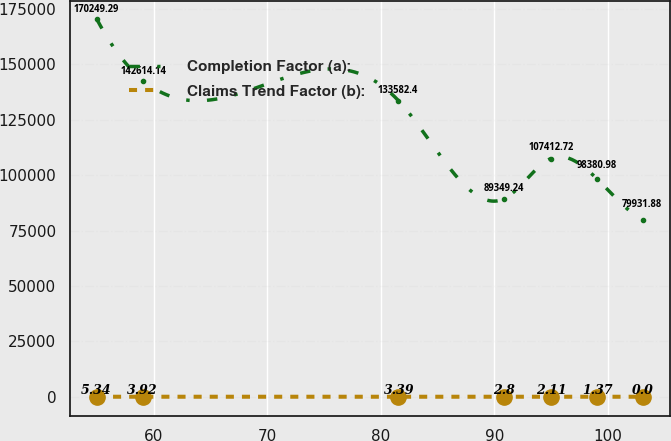Convert chart to OTSL. <chart><loc_0><loc_0><loc_500><loc_500><line_chart><ecel><fcel>Completion Factor (a):<fcel>Claims Trend Factor (b):<nl><fcel>55.01<fcel>170249<fcel>5.34<nl><fcel>59.09<fcel>142614<fcel>3.92<nl><fcel>81.56<fcel>133582<fcel>3.39<nl><fcel>90.87<fcel>89349.2<fcel>2.8<nl><fcel>94.95<fcel>107413<fcel>2.11<nl><fcel>99.03<fcel>98381<fcel>1.37<nl><fcel>103.11<fcel>79931.9<fcel>0<nl></chart> 